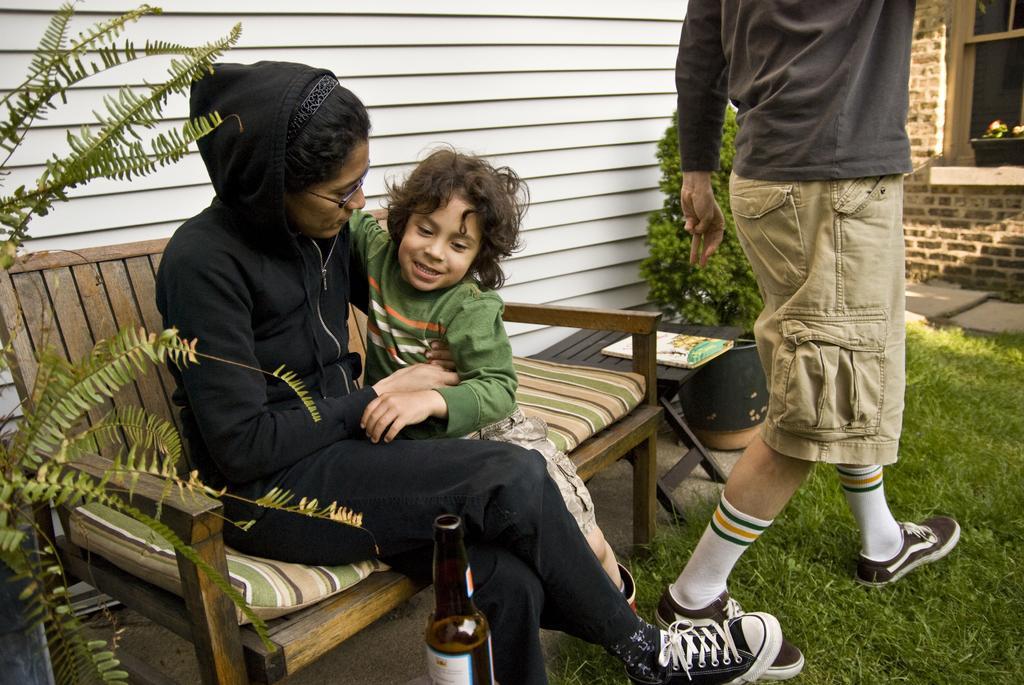Could you give a brief overview of what you see in this image? In this image there is a woman and a boy sitting in a bench, and in the back ground there is another person , plant , book , table , grass, building. 